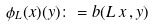Convert formula to latex. <formula><loc_0><loc_0><loc_500><loc_500>\phi _ { L } ( x ) ( y ) \colon = b ( L \, x \, , y )</formula> 